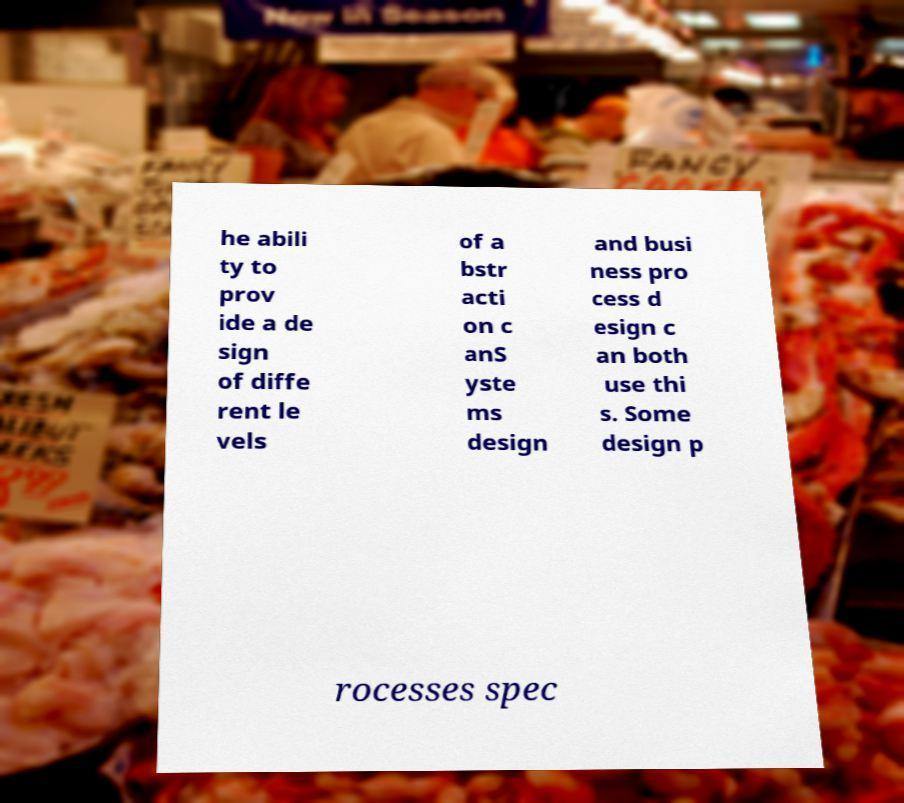Can you read and provide the text displayed in the image?This photo seems to have some interesting text. Can you extract and type it out for me? he abili ty to prov ide a de sign of diffe rent le vels of a bstr acti on c anS yste ms design and busi ness pro cess d esign c an both use thi s. Some design p rocesses spec 